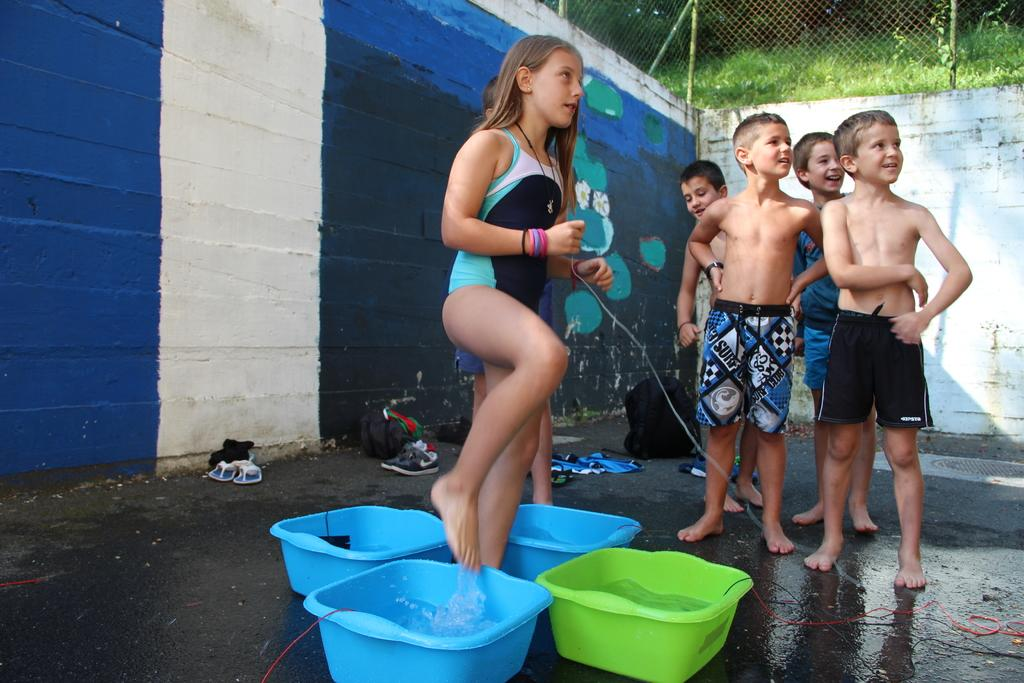Who is present in the image? There are kids in the image. What are the trays with in the image? The trays contain water. What can be seen in the background of the image? There is a wall with fencing on top, and grassland is visible. What type of pain can be seen on the kids' faces in the image? There is no indication of pain on the kids' faces in the image. Can you see any worms crawling on the grass in the background? There are no worms visible in the image; only the kids, trays with water, wall, fencing, and grassland can be seen. 